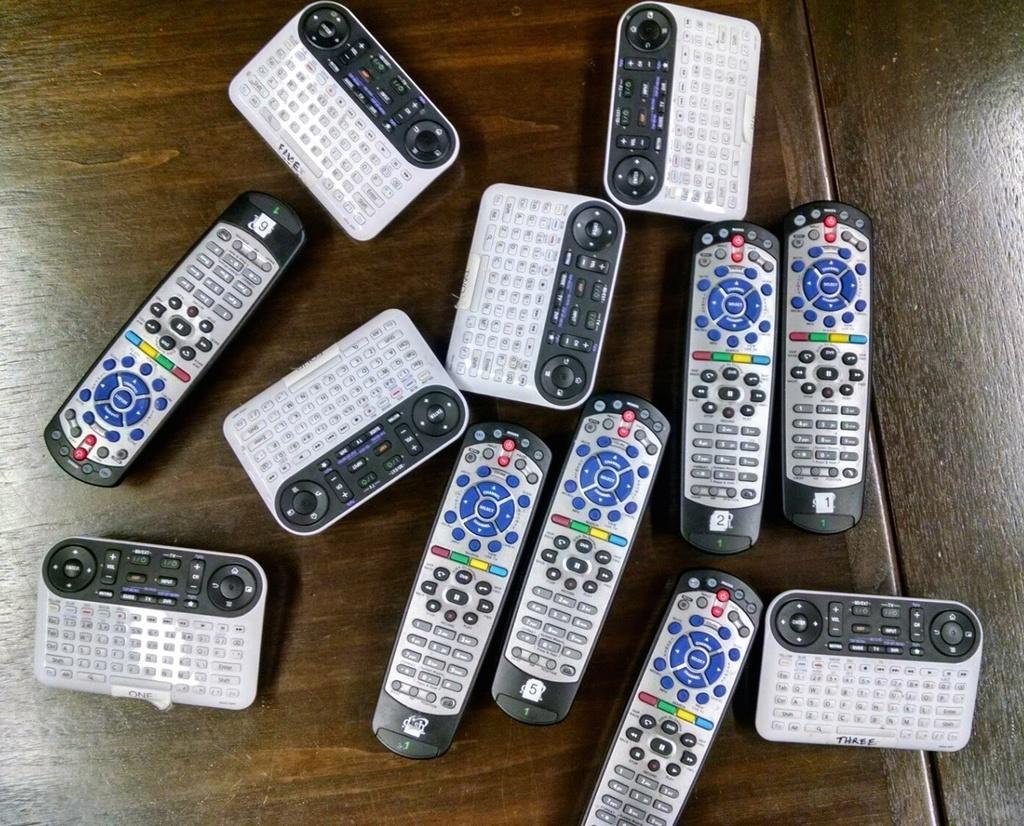<image>
Summarize the visual content of the image. Various types of Dish Network satellite receiver remote controls ona wooden table. 